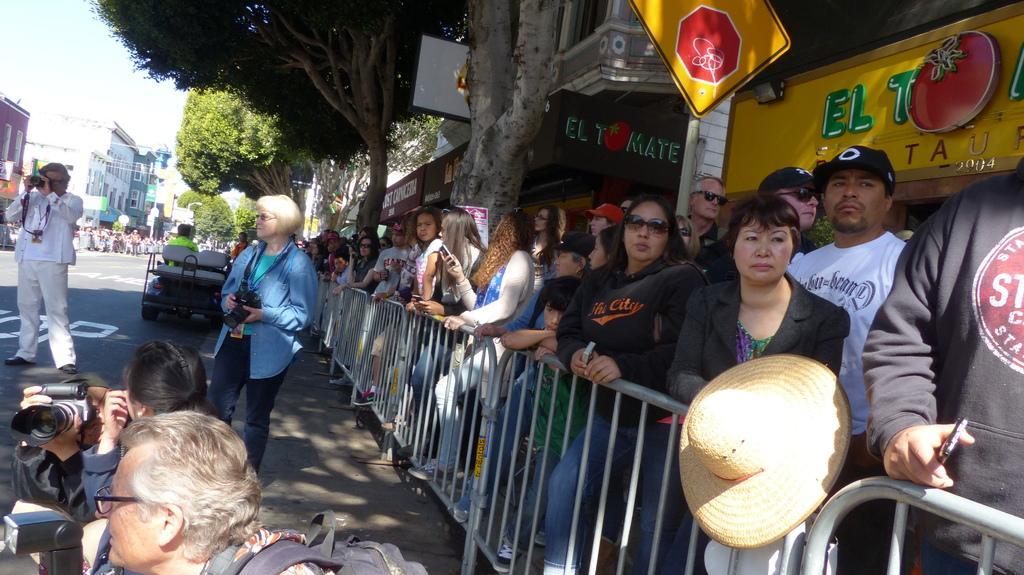Could you give a brief overview of what you see in this image? This image is clicked on the road. To the right there are many people standing. In front of them there is a railing. Behind them there are buildings. There are boards with text on the buildings. In front of the railing there are a few people slitting on the ground and they are holding cameras in their hands. There are two people standing on the ground. Behind them there is a vehicle. In the background there are buildings and trees. In the top left there is the sky. 